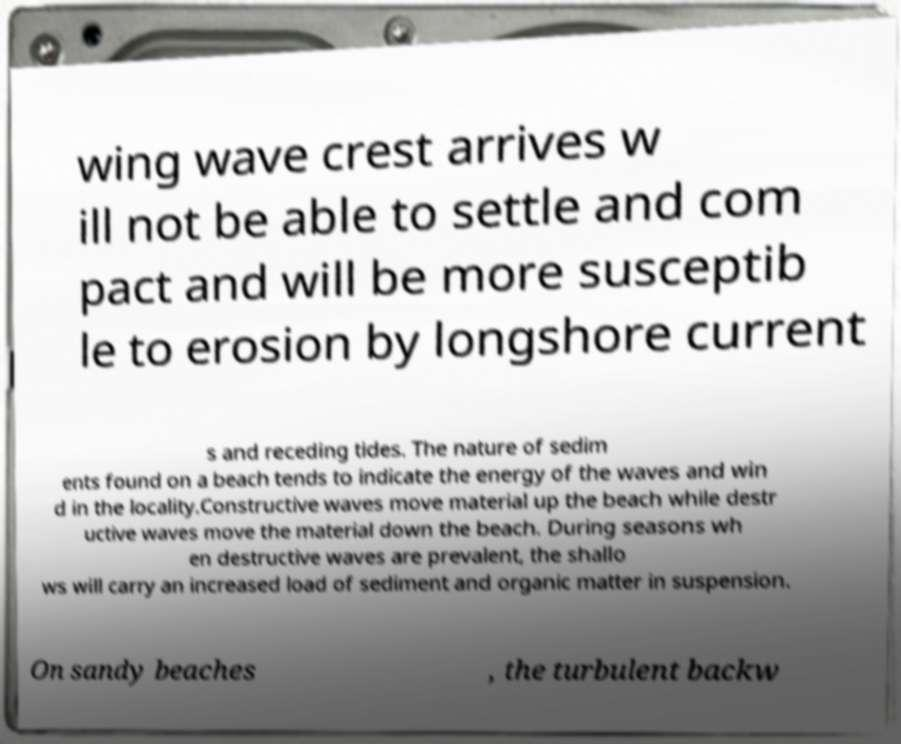I need the written content from this picture converted into text. Can you do that? wing wave crest arrives w ill not be able to settle and com pact and will be more susceptib le to erosion by longshore current s and receding tides. The nature of sedim ents found on a beach tends to indicate the energy of the waves and win d in the locality.Constructive waves move material up the beach while destr uctive waves move the material down the beach. During seasons wh en destructive waves are prevalent, the shallo ws will carry an increased load of sediment and organic matter in suspension. On sandy beaches , the turbulent backw 